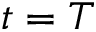Convert formula to latex. <formula><loc_0><loc_0><loc_500><loc_500>t = T</formula> 